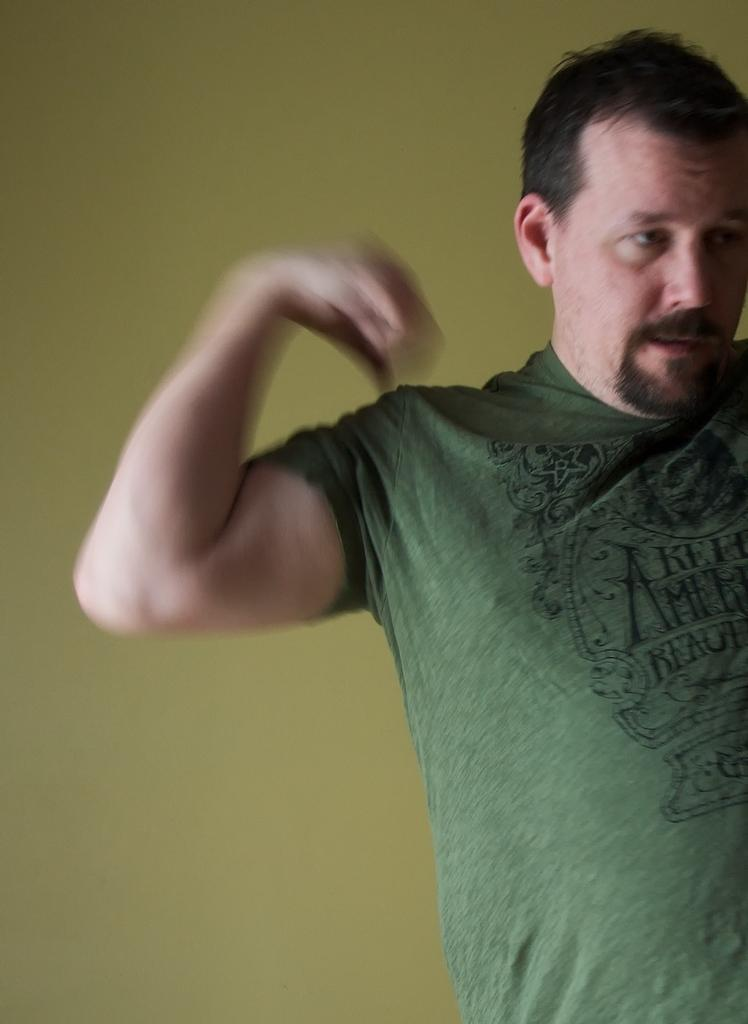Who is present in the image? There is a man in the image. What is the man doing in the image? The man is standing. What is the man wearing in the image? The man is wearing a green t-shirt. What can be seen in the background of the image? There is a wall in the background of the image. Is there a girl playing and kicking a ball in the image? No, there is no girl or ball present in the image. 